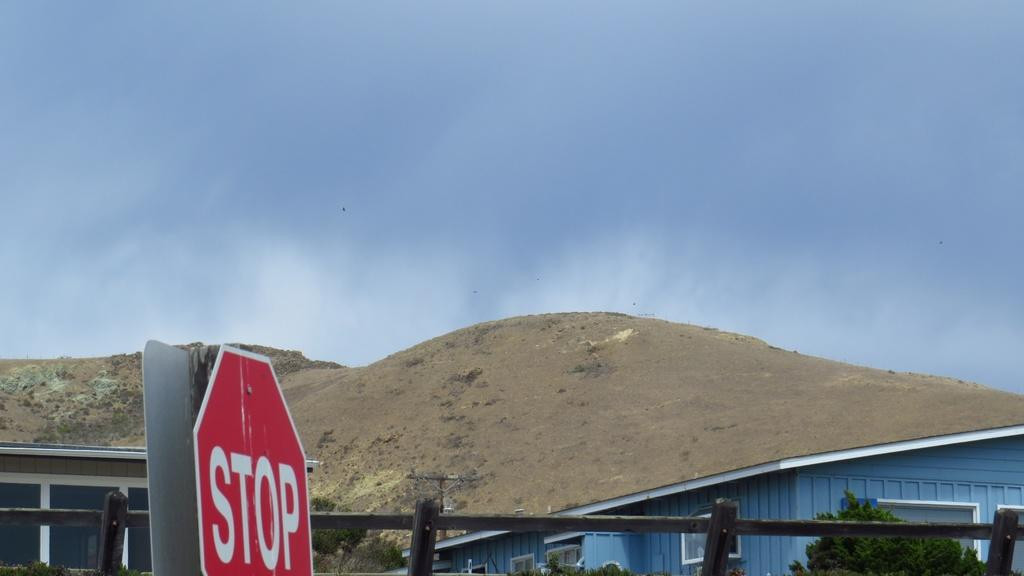Provide a one-sentence caption for the provided image. A view of a mountain next to a house and a stop sign is on the side of the road. 